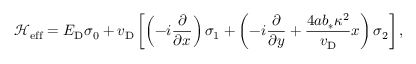<formula> <loc_0><loc_0><loc_500><loc_500>\mathcal { H } _ { e f f } = E _ { D } \sigma _ { 0 } + v _ { D } \left [ \left ( - i \frac { \partial } { \partial x } \right ) \sigma _ { 1 } + \left ( - i \frac { \partial } { \partial y } + \frac { 4 a b _ { * } \kappa ^ { 2 } } { v _ { D } } x \right ) \sigma _ { 2 } \right ] ,</formula> 